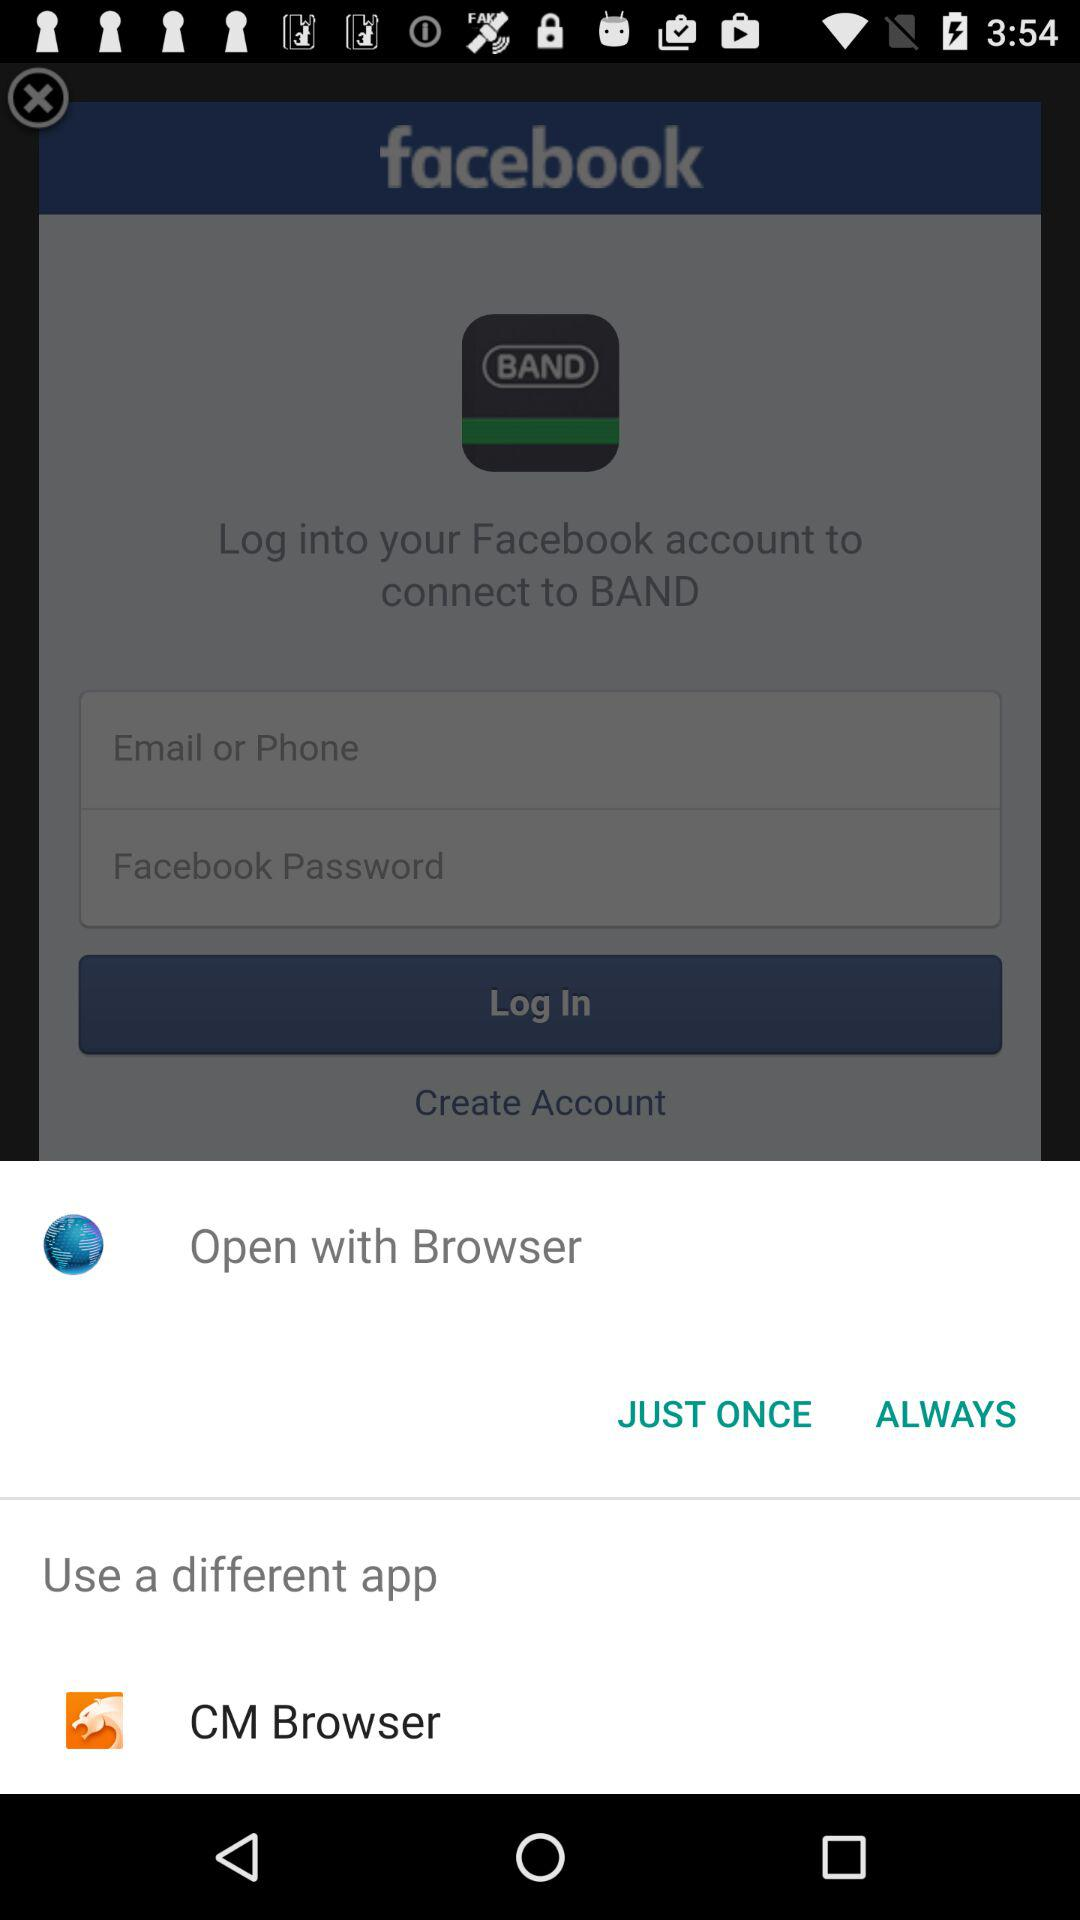What different apps can we use? You can use "CM Browser" as a different app. 